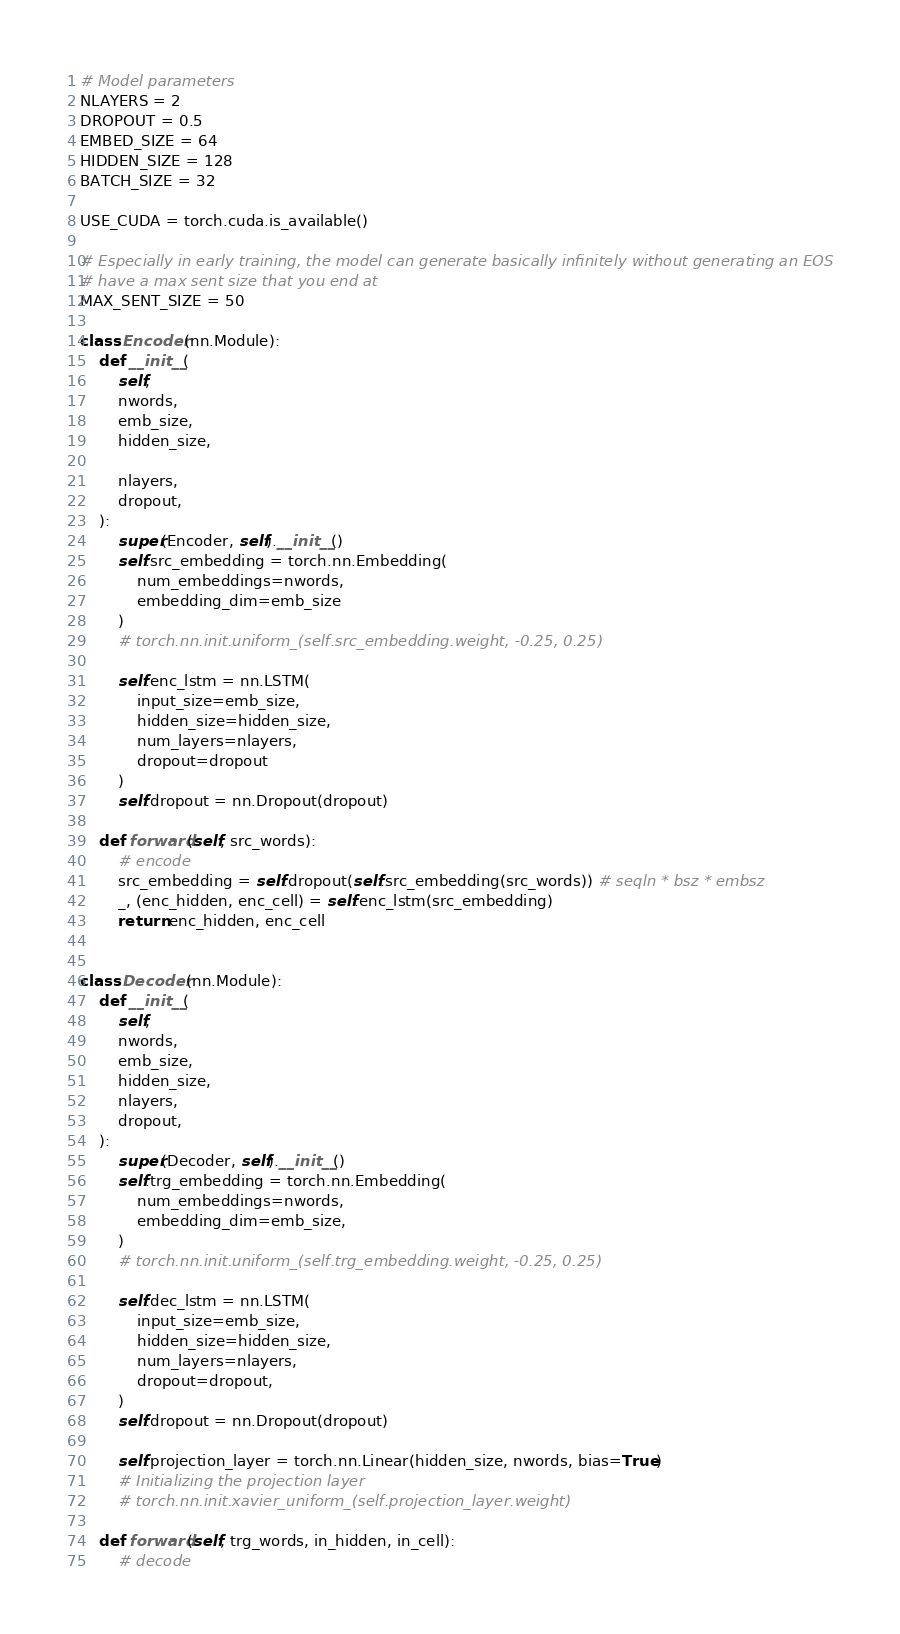Convert code to text. <code><loc_0><loc_0><loc_500><loc_500><_Python_>
# Model parameters
NLAYERS = 2
DROPOUT = 0.5
EMBED_SIZE = 64
HIDDEN_SIZE = 128
BATCH_SIZE = 32

USE_CUDA = torch.cuda.is_available()

# Especially in early training, the model can generate basically infinitely without generating an EOS
# have a max sent size that you end at
MAX_SENT_SIZE = 50

class Encoder(nn.Module):
    def __init__(
        self,
        nwords,
        emb_size,
        hidden_size,

        nlayers,
        dropout,
    ):
        super(Encoder, self).__init__()
        self.src_embedding = torch.nn.Embedding(
            num_embeddings=nwords,
            embedding_dim=emb_size
        )
        # torch.nn.init.uniform_(self.src_embedding.weight, -0.25, 0.25)

        self.enc_lstm = nn.LSTM(
            input_size=emb_size,
            hidden_size=hidden_size,
            num_layers=nlayers,
            dropout=dropout
        )
        self.dropout = nn.Dropout(dropout)

    def forward(self, src_words):
        # encode
        src_embedding = self.dropout(self.src_embedding(src_words)) # seqln * bsz * embsz
        _, (enc_hidden, enc_cell) = self.enc_lstm(src_embedding)
        return enc_hidden, enc_cell


class Decoder(nn.Module):
    def __init__(
        self,
        nwords,
        emb_size,
        hidden_size,
        nlayers,
        dropout,
    ):
        super(Decoder, self).__init__()
        self.trg_embedding = torch.nn.Embedding(
            num_embeddings=nwords,
            embedding_dim=emb_size,
        )
        # torch.nn.init.uniform_(self.trg_embedding.weight, -0.25, 0.25)

        self.dec_lstm = nn.LSTM(
            input_size=emb_size,
            hidden_size=hidden_size,
            num_layers=nlayers,
            dropout=dropout,
        )
        self.dropout = nn.Dropout(dropout)

        self.projection_layer = torch.nn.Linear(hidden_size, nwords, bias=True)
        # Initializing the projection layer
        # torch.nn.init.xavier_uniform_(self.projection_layer.weight)

    def forward(self, trg_words, in_hidden, in_cell):
        # decode</code> 